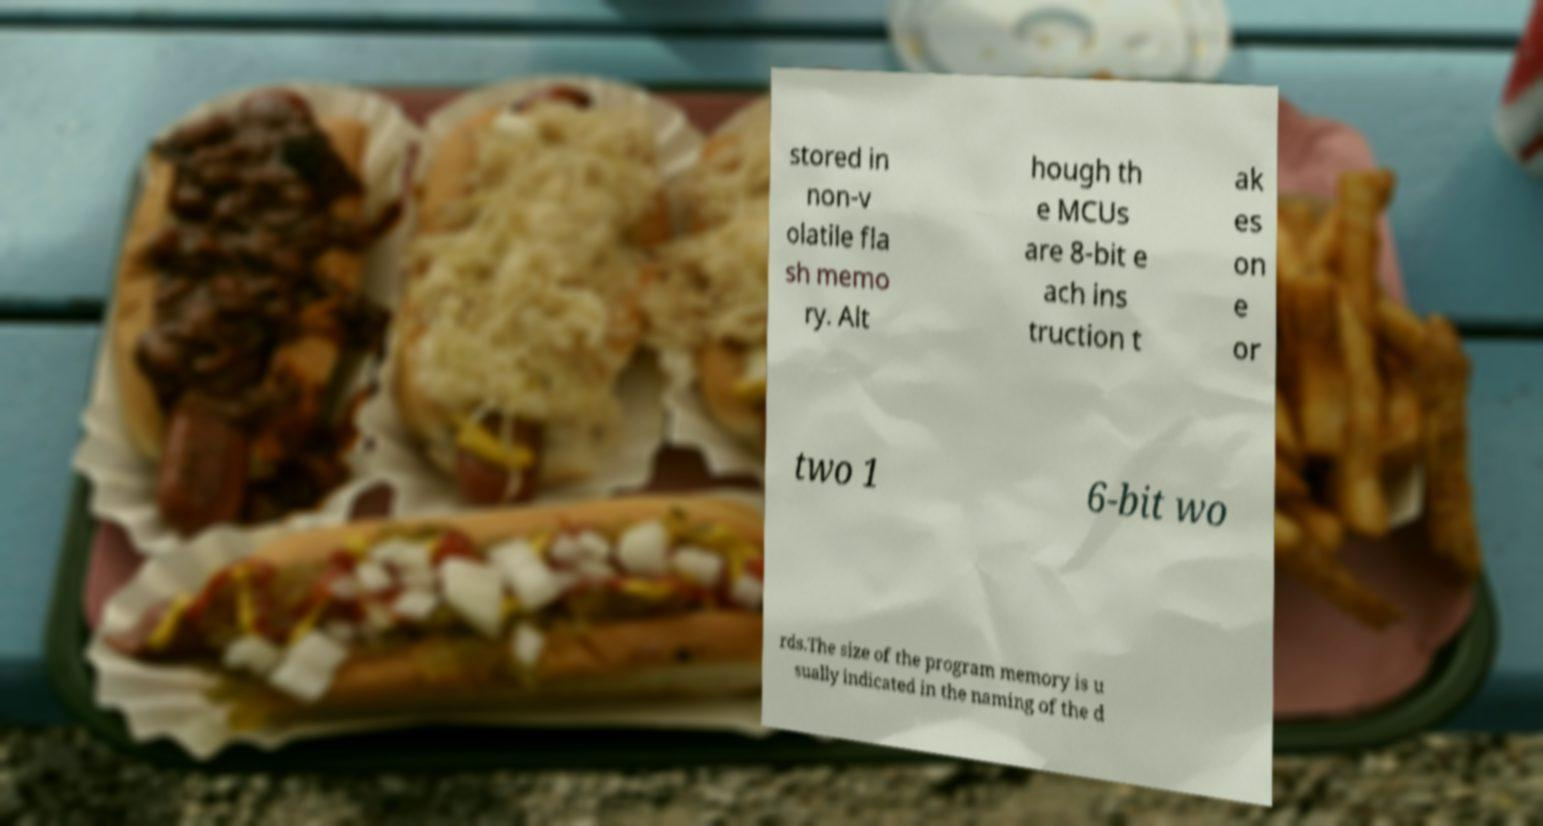Could you assist in decoding the text presented in this image and type it out clearly? stored in non-v olatile fla sh memo ry. Alt hough th e MCUs are 8-bit e ach ins truction t ak es on e or two 1 6-bit wo rds.The size of the program memory is u sually indicated in the naming of the d 